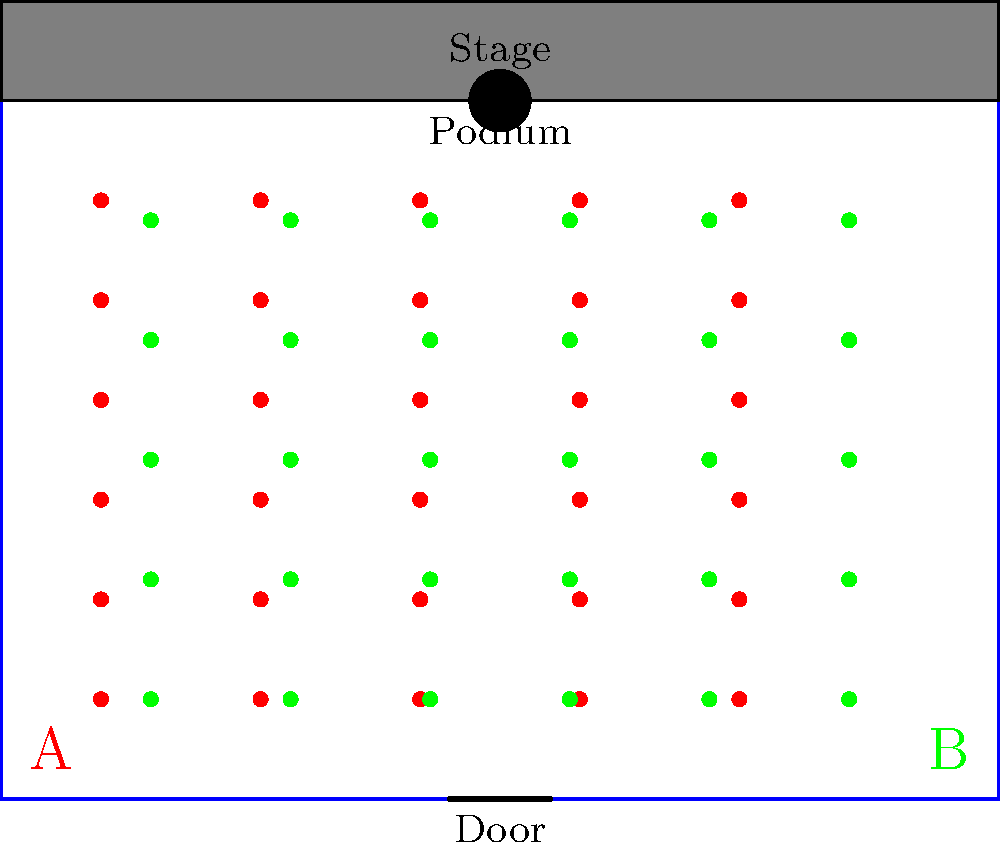Based on the floor plan diagram showing two different seating arrangements (A and B) for a press conference, which arrangement would you recommend to maximize audience engagement and facilitate better interaction between speakers and attendees? To evaluate the effectiveness of the seating arrangements, we need to consider several factors:

1. Proximity to the stage: 
   - Arrangement A has more seats closer to the stage, allowing better visibility and engagement for more attendees.
   - Arrangement B has fewer seats near the stage, with some attendees seated quite far back.

2. Central alignment:
   - Arrangement A is centered with the podium, providing a balanced view for all attendees.
   - Arrangement B is off-center, potentially causing sight line issues for those on the far right.

3. Aisle space:
   - Arrangement A has clear aisles between seat columns, facilitating movement and potential Q&A sessions.
   - Arrangement B has less defined aisles, which may hinder movement and interaction.

4. Capacity:
   - Arrangement A accommodates 30 seats (5 rows x 6 columns).
   - Arrangement B accommodates 30 seats (6 rows x 5 columns).

5. Exit accessibility:
   - Arrangement A provides easier access to the door for all attendees.
   - Arrangement B may create congestion near the door due to its layout.

Given these factors, Arrangement A is more effective for maximizing audience engagement and facilitating better interaction between speakers and attendees. It provides better proximity to the stage, balanced sight lines, clear aisles for movement, and easier access to exits, all of which contribute to a more engaging and interactive press conference environment.
Answer: Arrangement A 